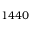Convert formula to latex. <formula><loc_0><loc_0><loc_500><loc_500>{ 1 4 4 0 }</formula> 